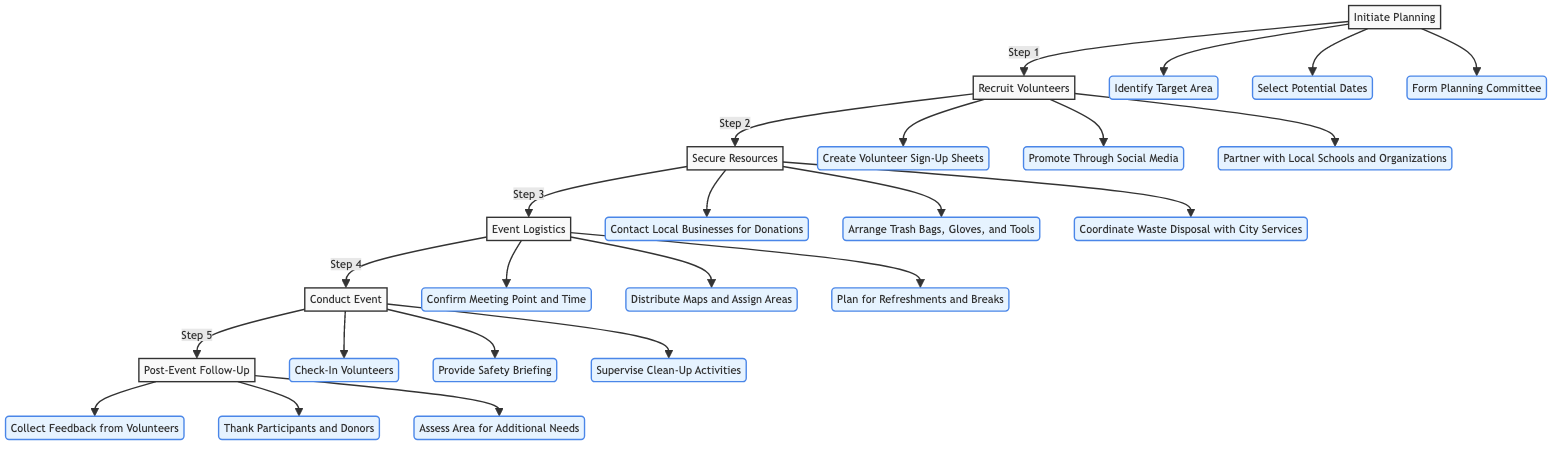What is the first step in the process? The diagram starts from "Initiate Planning," indicating that it is the first step in coordinating community clean-up events.
Answer: Initiate Planning How many main steps are there in the process? By counting the main nodes in the diagram, there are six steps numbered A through F.
Answer: 6 What follows after "Secure Resources"? The diagram shows that "Event Logistics" is the next step after "Secure Resources," demonstrating the flow from one phase to the next.
Answer: Event Logistics What action is associated with "Conduct Event"? The diagram lists three actions under "Conduct Event" which include checking in volunteers, providing a safety briefing, and supervising clean-up activities. However, the question asked specifically for one action, and hence, checking in volunteers is chosen as an illustrative action.
Answer: Check-In Volunteers Which step includes "Assess Area for Additional Needs"? "Post-Event Follow-Up" is the step where the action "Assess Area for Additional Needs" occurs, indicating it is a part of evaluating the event's effectiveness and requirements for future actions.
Answer: Post-Event Follow-Up How does "Recruit Volunteers" relate to "Conduct Event"? "Recruit Volunteers" leads to "Secure Resources," which is a prerequisite for "Event Logistics," which in turn leads to "Conduct Event," indicating a sequential relationship in the flow of activities leading to the event execution.
Answer: Sequential Relationship What is the last action in the flow chart? The final action listed under "Post-Event Follow-Up" is "Assess Area for Additional Needs," marking it as the conclusion of the clean-up event process.
Answer: Assess Area for Additional Needs Name one way to recruit volunteers as indicated in the diagram. The action "Promote Through Social Media" is one method listed for engaging community members to participate in the event.
Answer: Promote Through Social Media What is the primary purpose of "Event Logistics"? The purpose of "Event Logistics" is to finalize and communicate detailed logistics to all participants, ensuring proper organization for the clean-up event.
Answer: Finalize and communicate logistics 